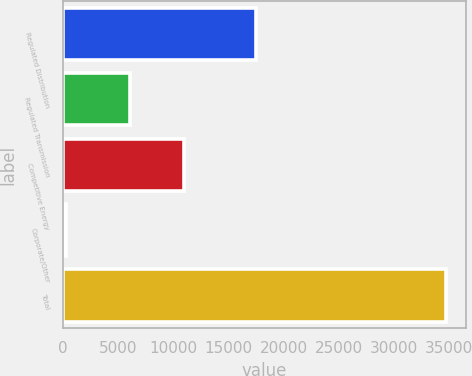Convert chart. <chart><loc_0><loc_0><loc_500><loc_500><bar_chart><fcel>Regulated Distribution<fcel>Regulated Transmission<fcel>Competitive Energy<fcel>Corporate/Other<fcel>Total<nl><fcel>17495<fcel>6056<fcel>11001<fcel>240<fcel>34792<nl></chart> 